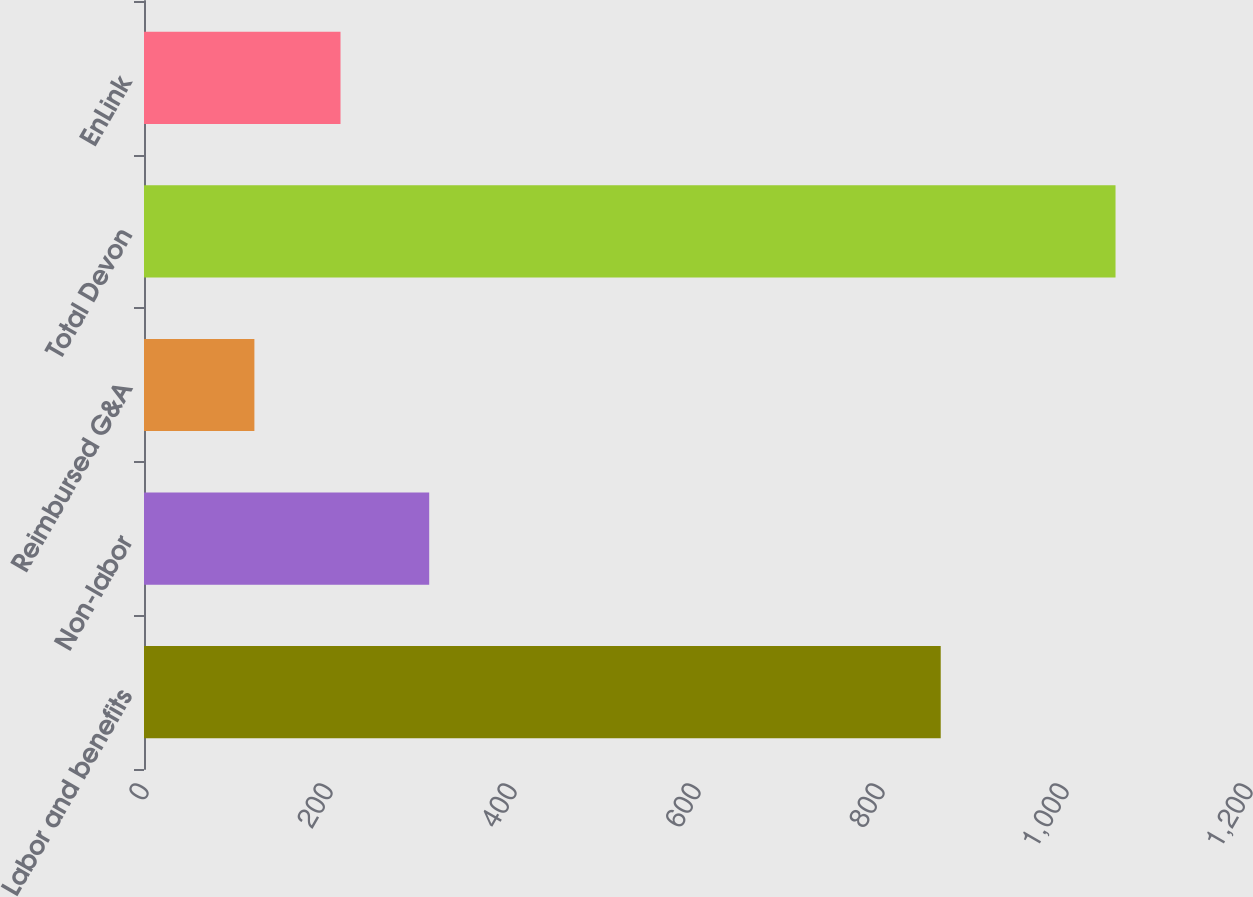<chart> <loc_0><loc_0><loc_500><loc_500><bar_chart><fcel>Labor and benefits<fcel>Non-labor<fcel>Reimbursed G&A<fcel>Total Devon<fcel>EnLink<nl><fcel>866<fcel>310<fcel>120<fcel>1056<fcel>213.6<nl></chart> 